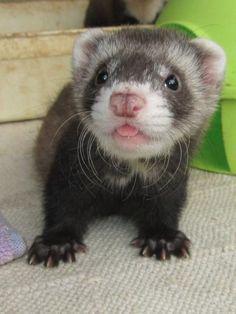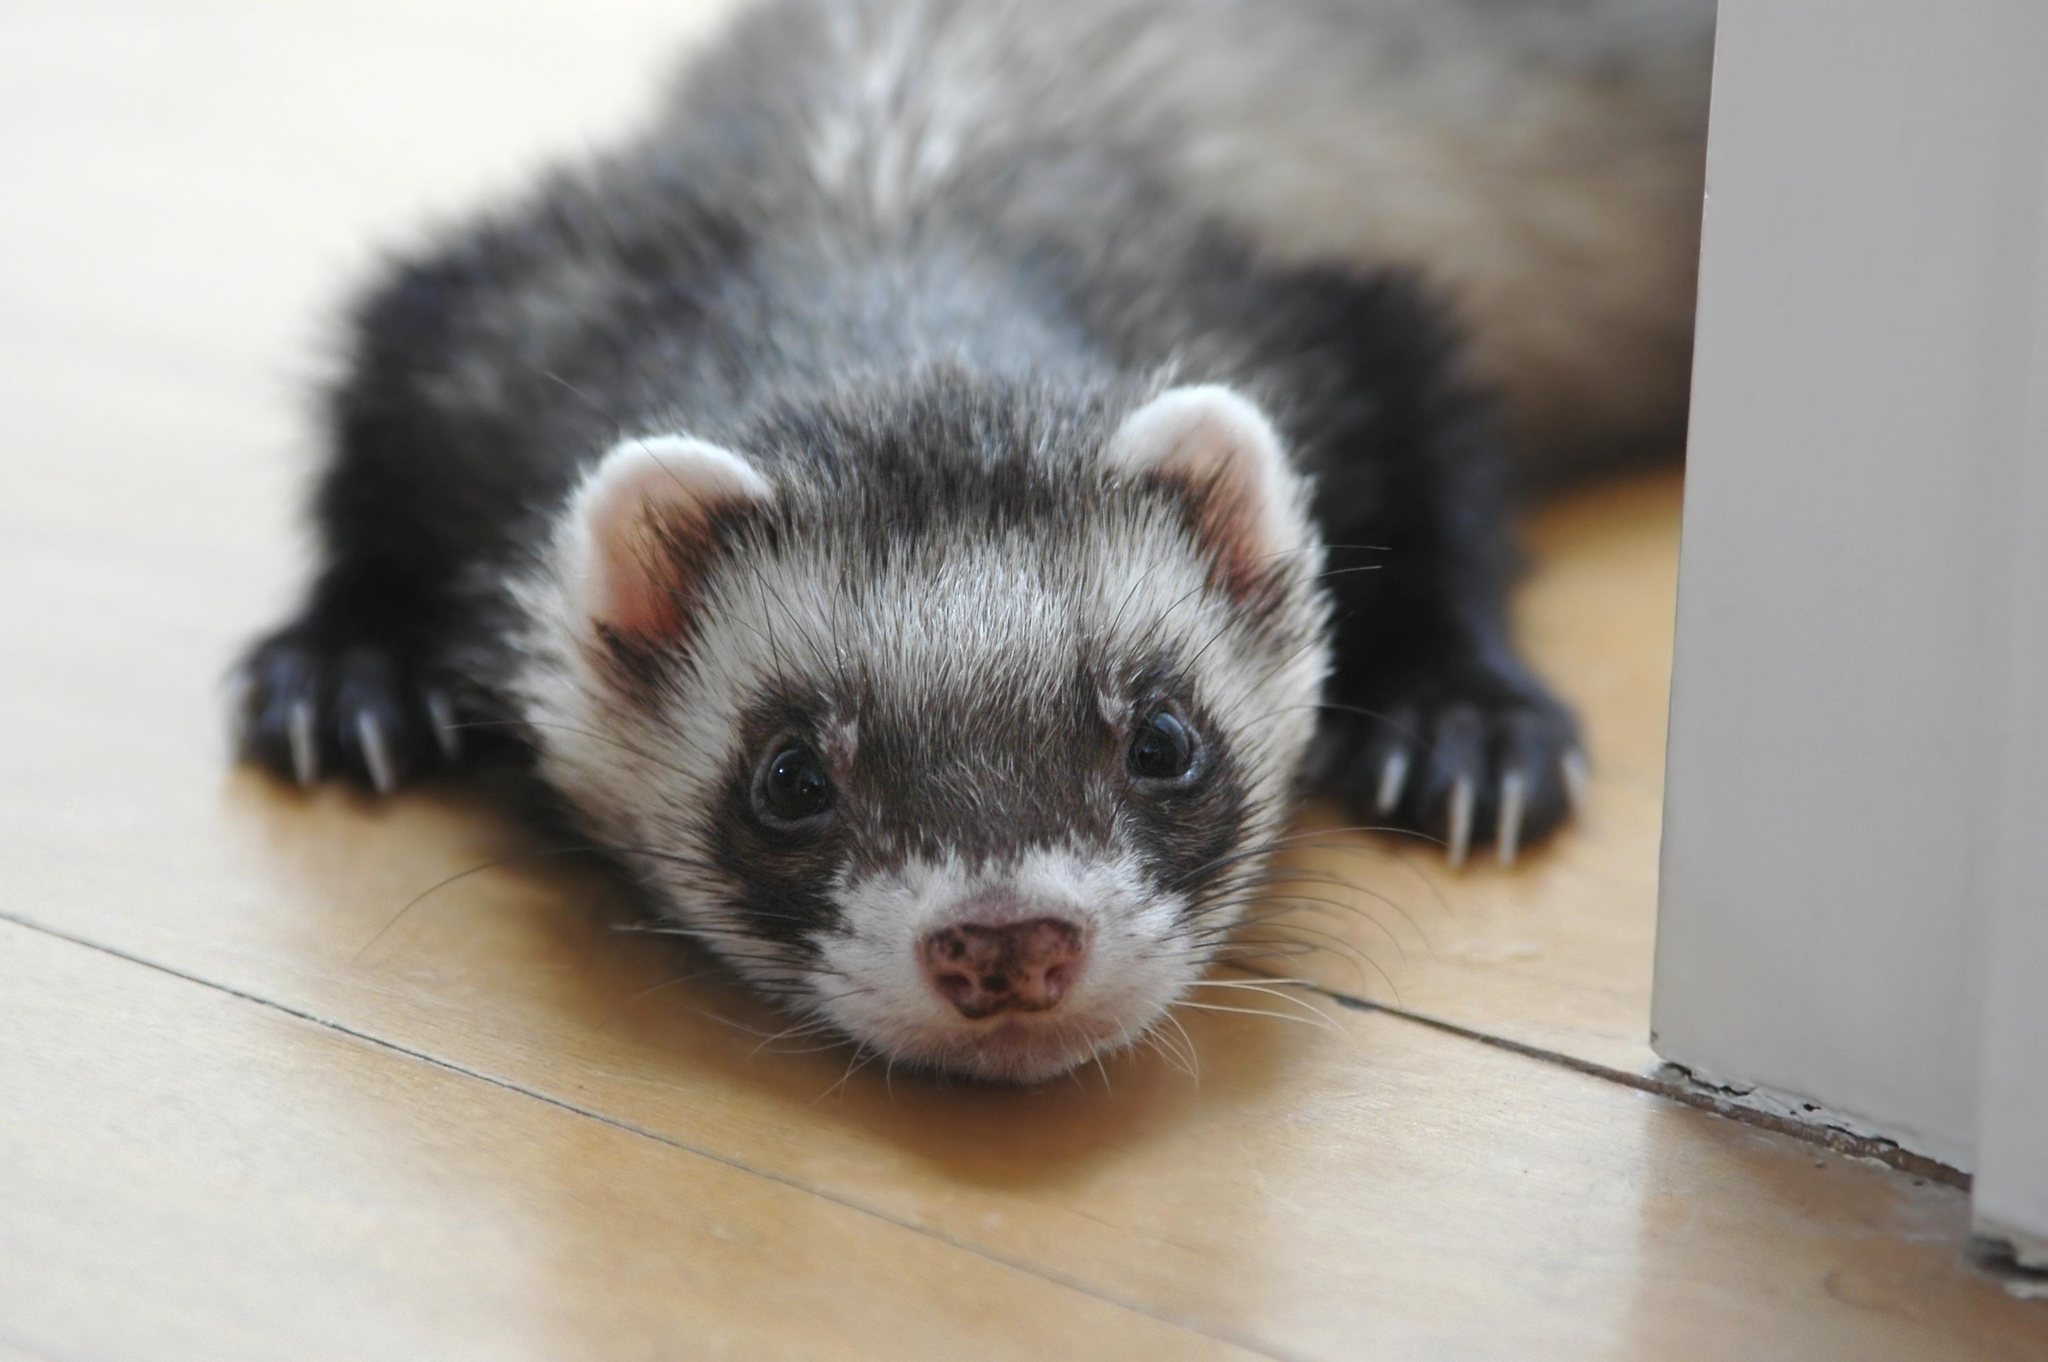The first image is the image on the left, the second image is the image on the right. Given the left and right images, does the statement "The left image contains two ferrets with their faces close together and their mouths open to some degree." hold true? Answer yes or no. No. The first image is the image on the left, the second image is the image on the right. Evaluate the accuracy of this statement regarding the images: "The left image contains two ferrets.". Is it true? Answer yes or no. No. 